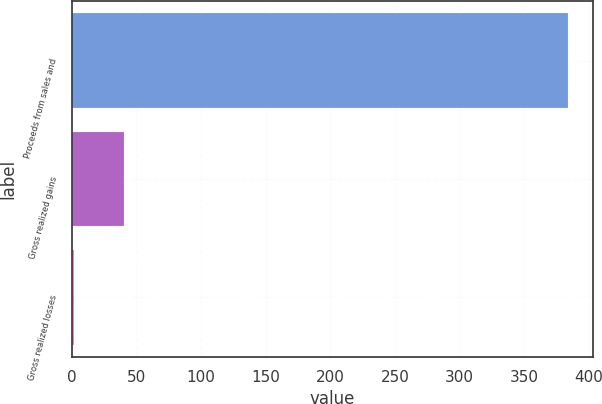Convert chart to OTSL. <chart><loc_0><loc_0><loc_500><loc_500><bar_chart><fcel>Proceeds from sales and<fcel>Gross realized gains<fcel>Gross realized losses<nl><fcel>384<fcel>40.2<fcel>2<nl></chart> 